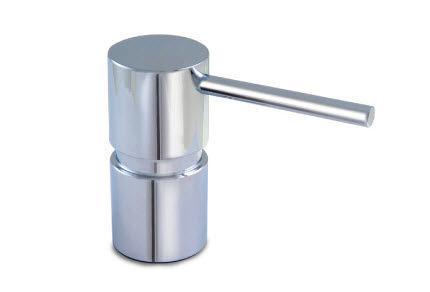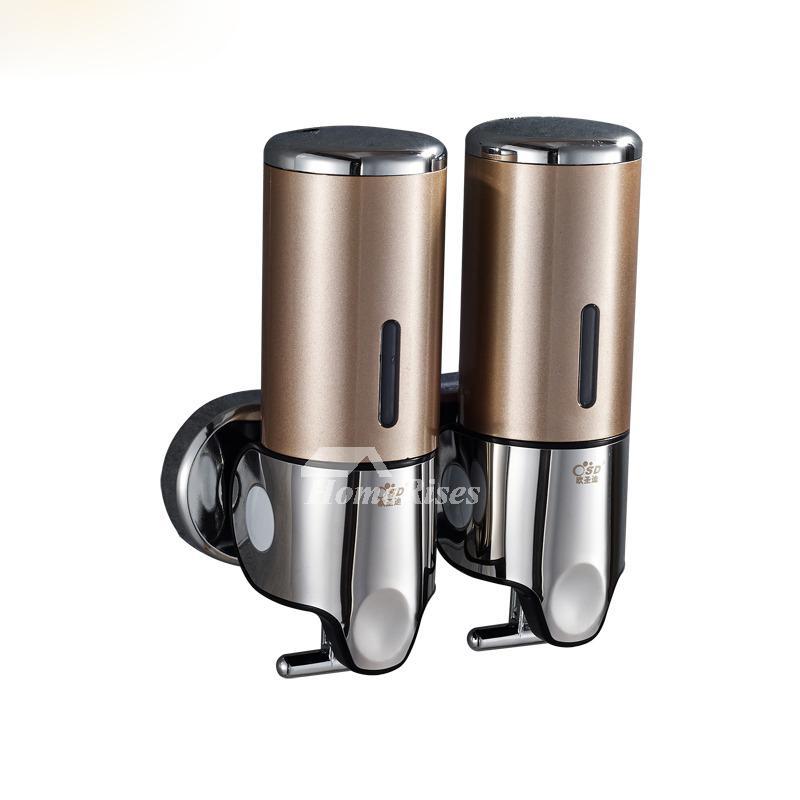The first image is the image on the left, the second image is the image on the right. Analyze the images presented: Is the assertion "The combined images include a wall-mount dispenser, a horizontal nozzle, and at least one chrome element." valid? Answer yes or no. Yes. The first image is the image on the left, the second image is the image on the right. Examine the images to the left and right. Is the description "There are two white dispensers." accurate? Answer yes or no. No. 